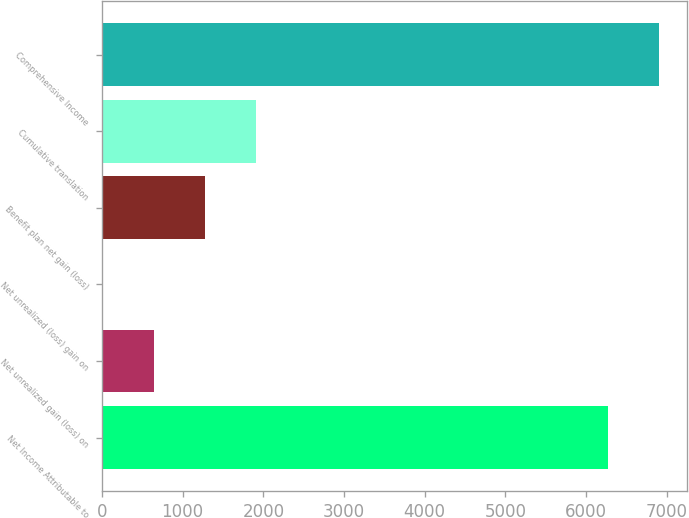Convert chart to OTSL. <chart><loc_0><loc_0><loc_500><loc_500><bar_chart><fcel>Net Income Attributable to<fcel>Net unrealized gain (loss) on<fcel>Net unrealized (loss) gain on<fcel>Benefit plan net gain (loss)<fcel>Cumulative translation<fcel>Comprehensive Income<nl><fcel>6272<fcel>644.6<fcel>10<fcel>1279.2<fcel>1913.8<fcel>6906.6<nl></chart> 